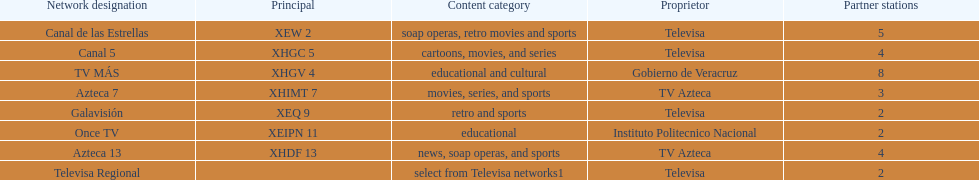How many networks have more affiliates than canal de las estrellas? 1. 